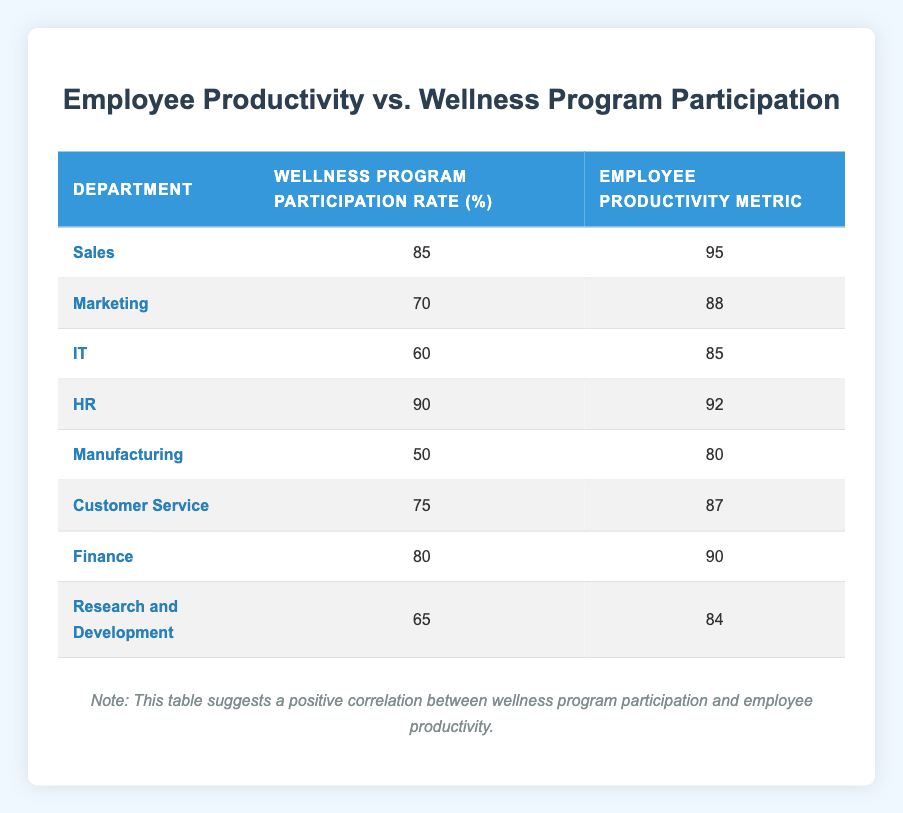What is the Wellness Program Participation Rate for the HR department? According to the table, the Wellness Program Participation Rate for the HR department is listed under the respective column, which shows a value of 90%.
Answer: 90% Which department has the highest Employee Productivity Metric? By observing the Employee Productivity Metric column, it is clear that the Sales department has the highest value at 95.
Answer: Sales What is the average Wellness Program Participation Rate across all departments? To find the average, sum the participation rates: (85 + 70 + 60 + 90 + 50 + 75 + 80 + 65) = 675. Then divide by the number of departments (8): 675 / 8 = 84.375.
Answer: 84.375 Is there a department with a Wellness Program Participation Rate below 60%? Looking through the Wellness Program Participation Rate column, the Manufacturing department has the lowest rate of 50%, which is indeed below 60%.
Answer: Yes What is the difference in Employee Productivity Metrics between the Sales and Manufacturing departments? The Employee Productivity Metric for Sales is 95 and for Manufacturing is 80. Thus, the difference is 95 - 80 = 15.
Answer: 15 Which two departments have the closest Employee Productivity Metrics? Analyzing the Employee Productivity Metric values, Marketing (88) and Customer Service (87) have the closest metrics, differing by just 1 point.
Answer: Marketing and Customer Service Is the average Employee Productivity Metric higher than 85? To assess this, first sum the metrics: (95 + 88 + 85 + 92 + 80 + 87 + 90 + 84) = 711. Then, divide by the number of departments (8): 711 / 8 = 88.875, which is higher than 85.
Answer: Yes What percentage of departments have a Wellness Program Participation Rate above 75%? There are 5 departments (Sales, HR, Finance) with participation rates above 75% out of 8 total departments. This is calculated as (5/8) * 100 = 62.5%.
Answer: 62.5% 